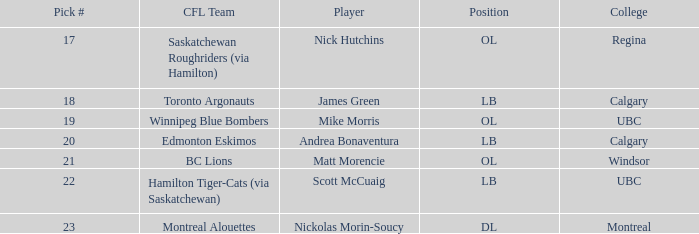What playing position does the athlete who transferred to regina hold? OL. 